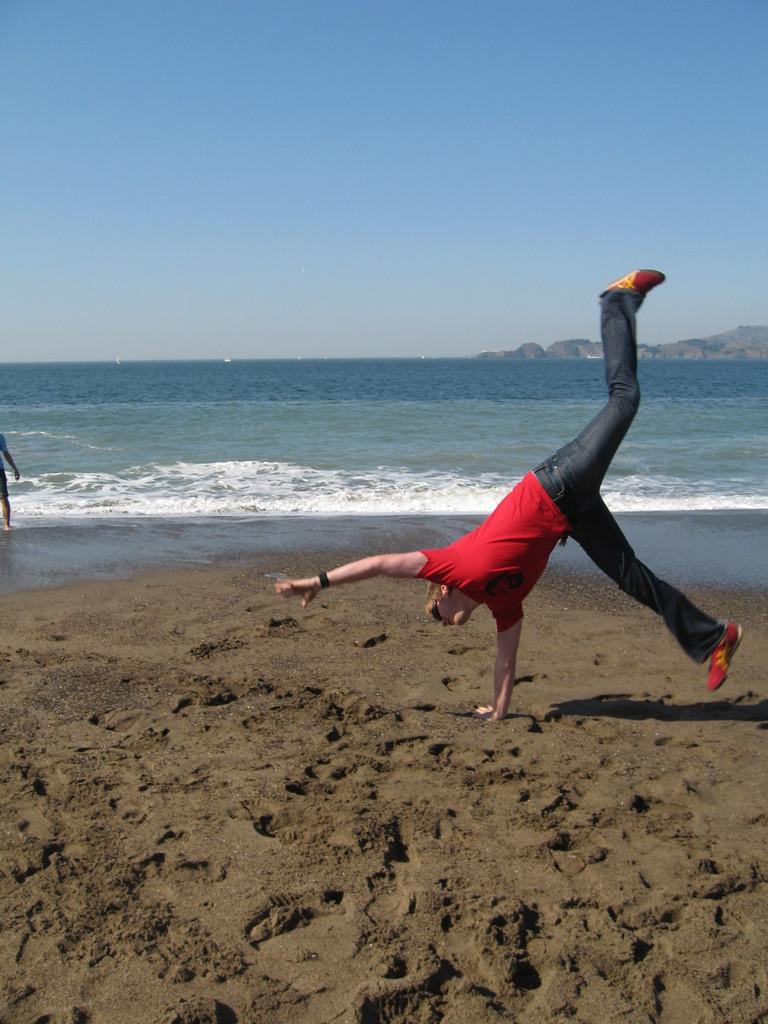What natural elements can be seen in the image? There is water and sand in the image. What is the person in the image wearing? The person is wearing a red t-shirt in the image. What is visible at the top of the image? The sky is visible at the top of the image. Is the person driving a vehicle in the image? There is no vehicle present in the image, so the person is not driving in the image. What type of twist can be seen in the image? There is no twist present in the image; it features water, sand, and a person wearing a red t-shirt. 